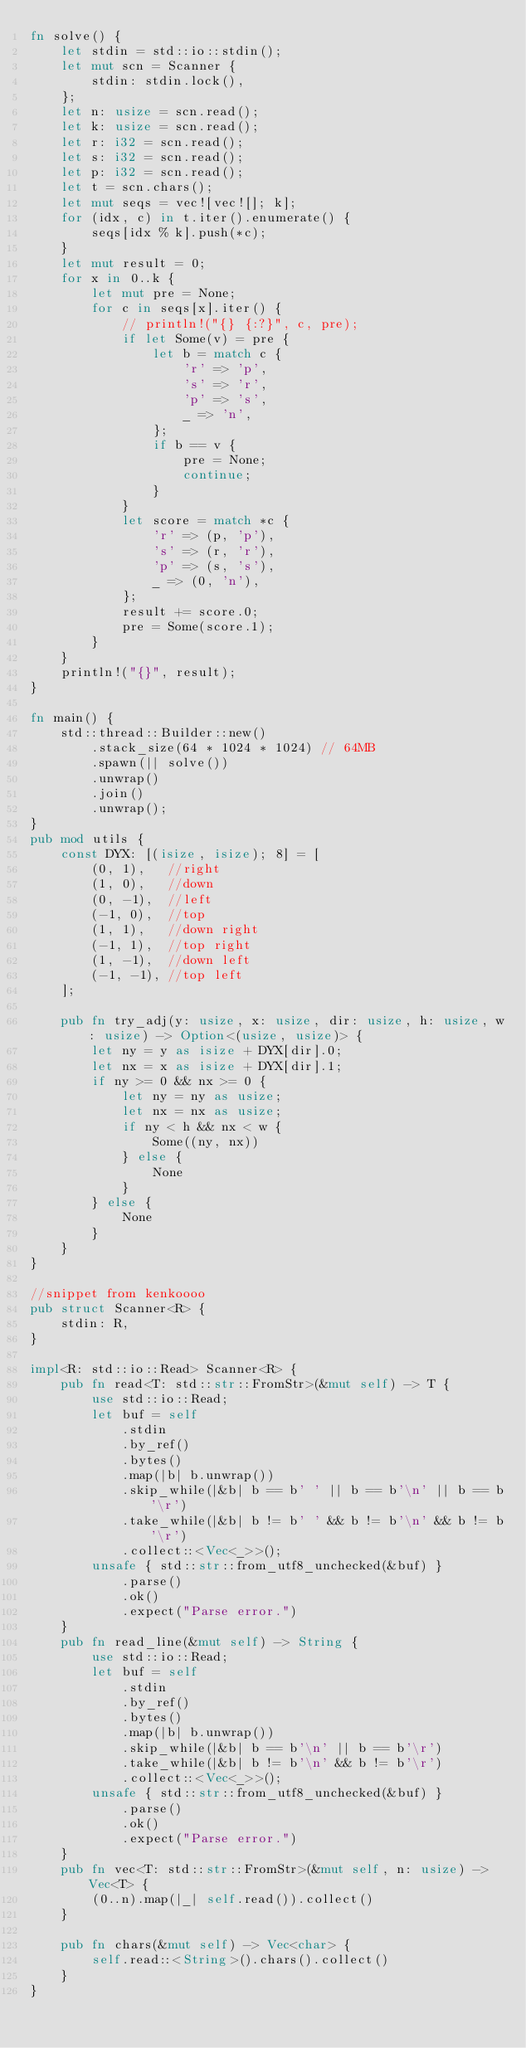<code> <loc_0><loc_0><loc_500><loc_500><_Rust_>fn solve() {
    let stdin = std::io::stdin();
    let mut scn = Scanner {
        stdin: stdin.lock(),
    };
    let n: usize = scn.read();
    let k: usize = scn.read();
    let r: i32 = scn.read();
    let s: i32 = scn.read();
    let p: i32 = scn.read();
    let t = scn.chars();
    let mut seqs = vec![vec![]; k];
    for (idx, c) in t.iter().enumerate() {
        seqs[idx % k].push(*c);
    }
    let mut result = 0;
    for x in 0..k {
        let mut pre = None;
        for c in seqs[x].iter() {
            // println!("{} {:?}", c, pre);
            if let Some(v) = pre {
                let b = match c {
                    'r' => 'p',
                    's' => 'r',
                    'p' => 's',
                    _ => 'n',
                };
                if b == v {
                    pre = None;
                    continue;
                }
            }
            let score = match *c {
                'r' => (p, 'p'),
                's' => (r, 'r'),
                'p' => (s, 's'),
                _ => (0, 'n'),
            };
            result += score.0;
            pre = Some(score.1);
        }
    }
    println!("{}", result);
}

fn main() {
    std::thread::Builder::new()
        .stack_size(64 * 1024 * 1024) // 64MB
        .spawn(|| solve())
        .unwrap()
        .join()
        .unwrap();
}
pub mod utils {
    const DYX: [(isize, isize); 8] = [
        (0, 1),   //right
        (1, 0),   //down
        (0, -1),  //left
        (-1, 0),  //top
        (1, 1),   //down right
        (-1, 1),  //top right
        (1, -1),  //down left
        (-1, -1), //top left
    ];

    pub fn try_adj(y: usize, x: usize, dir: usize, h: usize, w: usize) -> Option<(usize, usize)> {
        let ny = y as isize + DYX[dir].0;
        let nx = x as isize + DYX[dir].1;
        if ny >= 0 && nx >= 0 {
            let ny = ny as usize;
            let nx = nx as usize;
            if ny < h && nx < w {
                Some((ny, nx))
            } else {
                None
            }
        } else {
            None
        }
    }
}

//snippet from kenkoooo
pub struct Scanner<R> {
    stdin: R,
}

impl<R: std::io::Read> Scanner<R> {
    pub fn read<T: std::str::FromStr>(&mut self) -> T {
        use std::io::Read;
        let buf = self
            .stdin
            .by_ref()
            .bytes()
            .map(|b| b.unwrap())
            .skip_while(|&b| b == b' ' || b == b'\n' || b == b'\r')
            .take_while(|&b| b != b' ' && b != b'\n' && b != b'\r')
            .collect::<Vec<_>>();
        unsafe { std::str::from_utf8_unchecked(&buf) }
            .parse()
            .ok()
            .expect("Parse error.")
    }
    pub fn read_line(&mut self) -> String {
        use std::io::Read;
        let buf = self
            .stdin
            .by_ref()
            .bytes()
            .map(|b| b.unwrap())
            .skip_while(|&b| b == b'\n' || b == b'\r')
            .take_while(|&b| b != b'\n' && b != b'\r')
            .collect::<Vec<_>>();
        unsafe { std::str::from_utf8_unchecked(&buf) }
            .parse()
            .ok()
            .expect("Parse error.")
    }
    pub fn vec<T: std::str::FromStr>(&mut self, n: usize) -> Vec<T> {
        (0..n).map(|_| self.read()).collect()
    }

    pub fn chars(&mut self) -> Vec<char> {
        self.read::<String>().chars().collect()
    }
}
</code> 